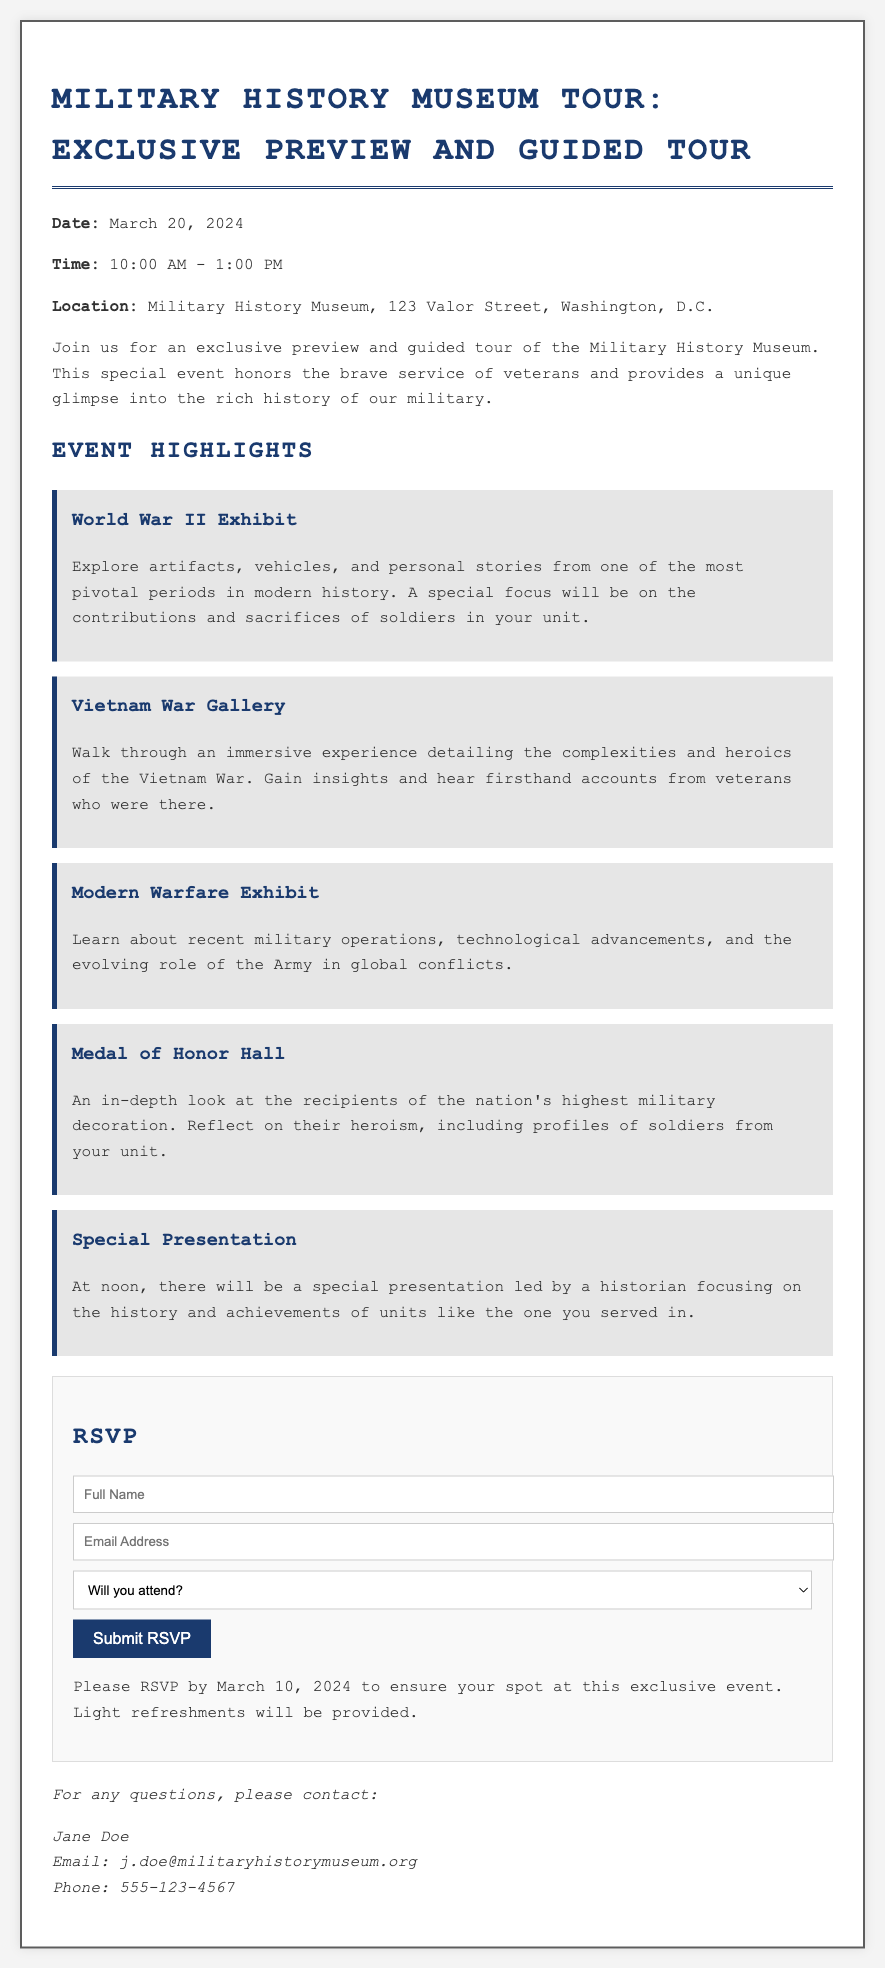What is the date of the event? The date of the event is specifically mentioned in the document as March 20, 2024.
Answer: March 20, 2024 What time does the event start? The beginning time for the event is stated clearly as 10:00 AM.
Answer: 10:00 AM What is the location of the Military History Museum? The address where the event is taking place is provided as 123 Valor Street, Washington, D.C.
Answer: 123 Valor Street, Washington, D.C What will be served at the event? The document mentions that light refreshments will be provided during the event.
Answer: Light refreshments How many main exhibits are highlighted in the document? The document lists five key exhibit areas, indicating the number of highlighted exhibits.
Answer: Five What is the RSVP deadline? The last date to respond is given in the document as March 10, 2024.
Answer: March 10, 2024 Who is leading the special presentation? The name or title of the person leading the presentation is not stated, but it mentions that a historian will lead it.
Answer: Historian What thematic focus does the World War II Exhibit have? The thematic focus of the World War II exhibit includes contributions and sacrifices of soldiers in your unit.
Answer: Contributions and sacrifices What requirement is needed to complete the RSVP form? The RSVP form requires the completion of fields for full name and email address along with an attendance confirmation.
Answer: Full name and email address 